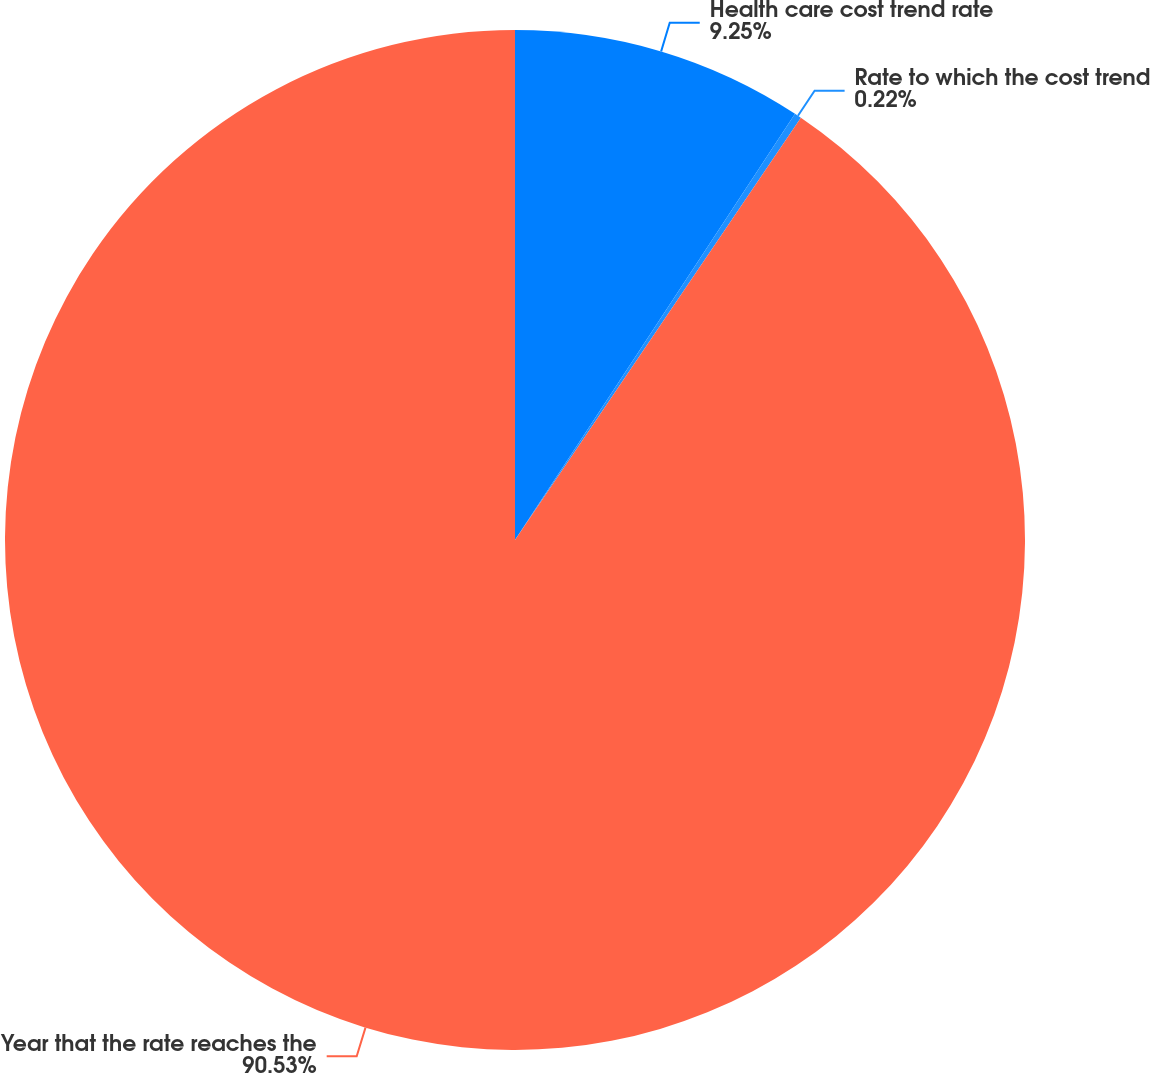<chart> <loc_0><loc_0><loc_500><loc_500><pie_chart><fcel>Health care cost trend rate<fcel>Rate to which the cost trend<fcel>Year that the rate reaches the<nl><fcel>9.25%<fcel>0.22%<fcel>90.52%<nl></chart> 